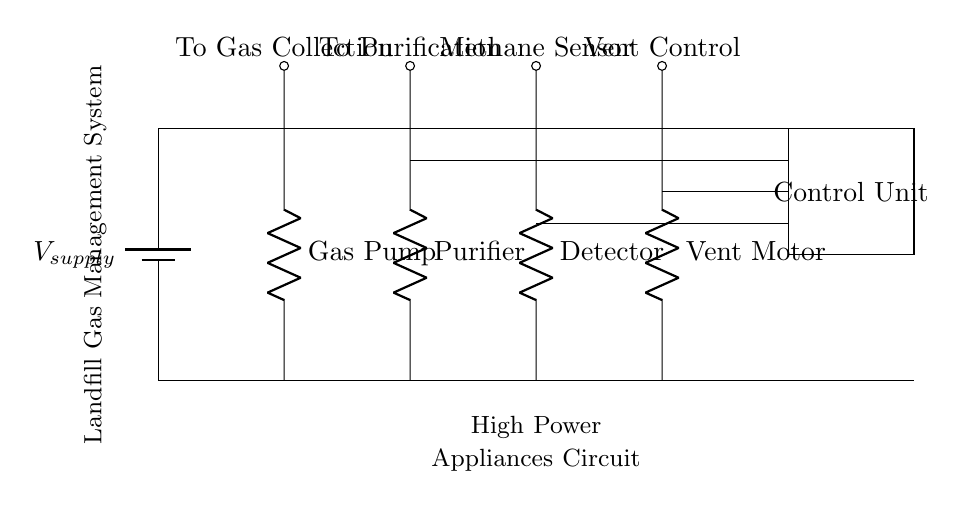What is the main power source for this circuit? The main power source is represented by the battery symbol. It supplies power to the entire landfill gas management system. In the circuit, it's indicated as V_supply, so we identify this immediately from the battery label.
Answer: Battery How many resistors are used in this circuit? In the circuit diagram, there are four resistors labeled as Gas Pump, Purifier, Detector, and Vent Motor. Each of these components is connected to different systems within the overall landfill gas management setup. By counting each labeled resistor, we find there are four in total.
Answer: Four What component is responsible for methane detection? The component labeled as Detector corresponds to the methane detection function. It is specifically designed to sense methane levels within the collected landfill gas. By referring directly to the labels in the diagram, we can easily identify this component.
Answer: Detector Which component controls the venting process? The Vent Control is the component that automates the venting process in this circuit. It is labeled distinctly in the circuit, indicating its purpose and functionality related to managing gas release from the system.
Answer: Vent Control What is the role of the control unit in this circuit? The Control Unit manages the operation of the entire landfill gas collection and purification system. It coordinates the activities between various components like the gas pump, purifier, detector, and vent motor to ensure the system operates safely and efficiently. The physical representation in the diagram shows it as a rectangular block connecting with various circuit paths.
Answer: Management 